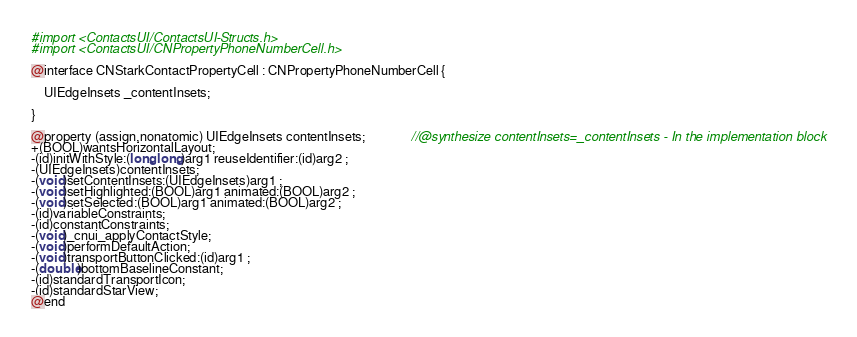<code> <loc_0><loc_0><loc_500><loc_500><_C_>#import <ContactsUI/ContactsUI-Structs.h>
#import <ContactsUI/CNPropertyPhoneNumberCell.h>

@interface CNStarkContactPropertyCell : CNPropertyPhoneNumberCell {

	UIEdgeInsets _contentInsets;

}

@property (assign,nonatomic) UIEdgeInsets contentInsets;              //@synthesize contentInsets=_contentInsets - In the implementation block
+(BOOL)wantsHorizontalLayout;
-(id)initWithStyle:(long long)arg1 reuseIdentifier:(id)arg2 ;
-(UIEdgeInsets)contentInsets;
-(void)setContentInsets:(UIEdgeInsets)arg1 ;
-(void)setHighlighted:(BOOL)arg1 animated:(BOOL)arg2 ;
-(void)setSelected:(BOOL)arg1 animated:(BOOL)arg2 ;
-(id)variableConstraints;
-(id)constantConstraints;
-(void)_cnui_applyContactStyle;
-(void)performDefaultAction;
-(void)transportButtonClicked:(id)arg1 ;
-(double)bottomBaselineConstant;
-(id)standardTransportIcon;
-(id)standardStarView;
@end

</code> 